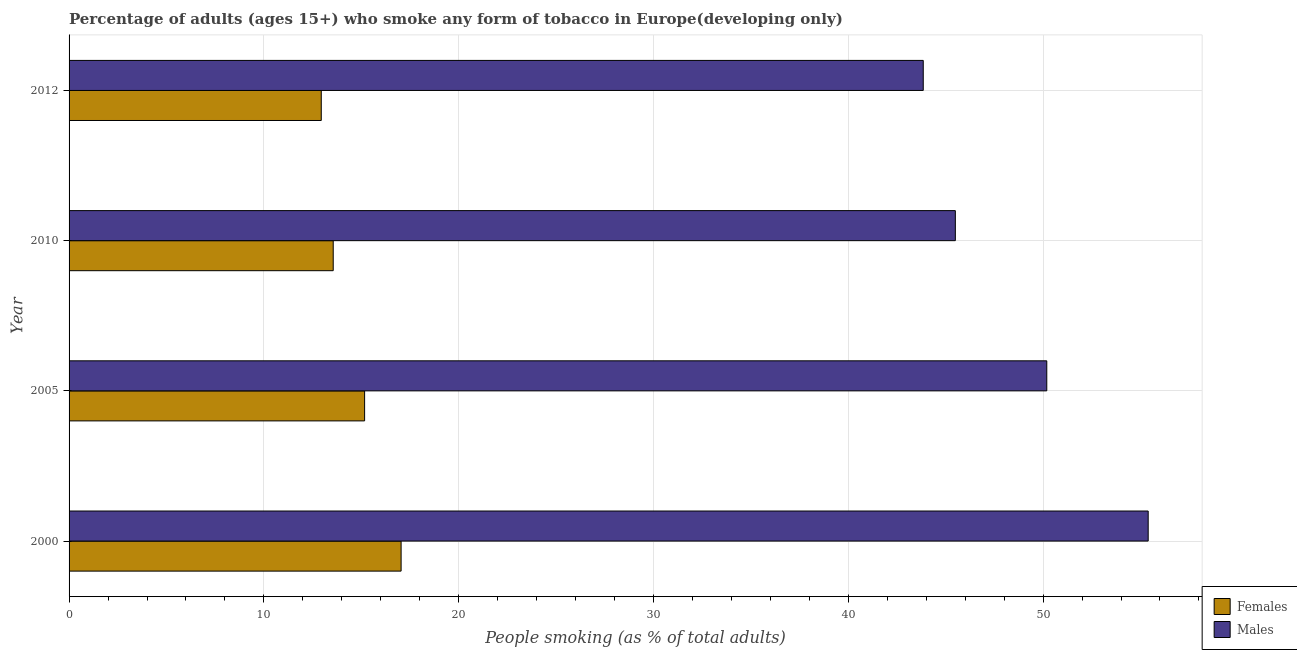How many different coloured bars are there?
Provide a succinct answer. 2. Are the number of bars on each tick of the Y-axis equal?
Your answer should be very brief. Yes. What is the label of the 1st group of bars from the top?
Your answer should be compact. 2012. In how many cases, is the number of bars for a given year not equal to the number of legend labels?
Provide a succinct answer. 0. What is the percentage of males who smoke in 2005?
Your answer should be very brief. 50.19. Across all years, what is the maximum percentage of males who smoke?
Your answer should be compact. 55.4. Across all years, what is the minimum percentage of females who smoke?
Give a very brief answer. 12.95. In which year was the percentage of males who smoke minimum?
Your response must be concise. 2012. What is the total percentage of males who smoke in the graph?
Provide a short and direct response. 194.93. What is the difference between the percentage of females who smoke in 2010 and that in 2012?
Your response must be concise. 0.61. What is the difference between the percentage of males who smoke in 2000 and the percentage of females who smoke in 2005?
Make the answer very short. 40.22. What is the average percentage of females who smoke per year?
Your answer should be very brief. 14.68. In the year 2005, what is the difference between the percentage of females who smoke and percentage of males who smoke?
Offer a very short reply. -35.02. In how many years, is the percentage of males who smoke greater than 50 %?
Your answer should be compact. 2. What is the ratio of the percentage of females who smoke in 2000 to that in 2010?
Provide a succinct answer. 1.26. What is the difference between the highest and the second highest percentage of females who smoke?
Give a very brief answer. 1.87. What is the difference between the highest and the lowest percentage of males who smoke?
Your answer should be compact. 11.55. What does the 1st bar from the top in 2010 represents?
Offer a terse response. Males. What does the 2nd bar from the bottom in 2010 represents?
Provide a succinct answer. Males. Are all the bars in the graph horizontal?
Keep it short and to the point. Yes. How many years are there in the graph?
Provide a short and direct response. 4. What is the difference between two consecutive major ticks on the X-axis?
Your answer should be very brief. 10. Are the values on the major ticks of X-axis written in scientific E-notation?
Provide a short and direct response. No. How are the legend labels stacked?
Ensure brevity in your answer.  Vertical. What is the title of the graph?
Your answer should be very brief. Percentage of adults (ages 15+) who smoke any form of tobacco in Europe(developing only). Does "Ages 15-24" appear as one of the legend labels in the graph?
Keep it short and to the point. No. What is the label or title of the X-axis?
Make the answer very short. People smoking (as % of total adults). What is the label or title of the Y-axis?
Provide a succinct answer. Year. What is the People smoking (as % of total adults) of Females in 2000?
Your answer should be very brief. 17.04. What is the People smoking (as % of total adults) of Males in 2000?
Give a very brief answer. 55.4. What is the People smoking (as % of total adults) of Females in 2005?
Make the answer very short. 15.17. What is the People smoking (as % of total adults) of Males in 2005?
Make the answer very short. 50.19. What is the People smoking (as % of total adults) in Females in 2010?
Your answer should be very brief. 13.56. What is the People smoking (as % of total adults) in Males in 2010?
Offer a terse response. 45.5. What is the People smoking (as % of total adults) in Females in 2012?
Give a very brief answer. 12.95. What is the People smoking (as % of total adults) in Males in 2012?
Provide a short and direct response. 43.85. Across all years, what is the maximum People smoking (as % of total adults) of Females?
Make the answer very short. 17.04. Across all years, what is the maximum People smoking (as % of total adults) of Males?
Your response must be concise. 55.4. Across all years, what is the minimum People smoking (as % of total adults) of Females?
Keep it short and to the point. 12.95. Across all years, what is the minimum People smoking (as % of total adults) in Males?
Keep it short and to the point. 43.85. What is the total People smoking (as % of total adults) of Females in the graph?
Give a very brief answer. 58.72. What is the total People smoking (as % of total adults) in Males in the graph?
Provide a succinct answer. 194.93. What is the difference between the People smoking (as % of total adults) of Females in 2000 and that in 2005?
Your answer should be very brief. 1.87. What is the difference between the People smoking (as % of total adults) in Males in 2000 and that in 2005?
Ensure brevity in your answer.  5.21. What is the difference between the People smoking (as % of total adults) of Females in 2000 and that in 2010?
Ensure brevity in your answer.  3.48. What is the difference between the People smoking (as % of total adults) of Males in 2000 and that in 2010?
Give a very brief answer. 9.9. What is the difference between the People smoking (as % of total adults) of Females in 2000 and that in 2012?
Give a very brief answer. 4.1. What is the difference between the People smoking (as % of total adults) of Males in 2000 and that in 2012?
Give a very brief answer. 11.55. What is the difference between the People smoking (as % of total adults) of Females in 2005 and that in 2010?
Make the answer very short. 1.61. What is the difference between the People smoking (as % of total adults) in Males in 2005 and that in 2010?
Your answer should be compact. 4.69. What is the difference between the People smoking (as % of total adults) in Females in 2005 and that in 2012?
Your answer should be very brief. 2.22. What is the difference between the People smoking (as % of total adults) in Males in 2005 and that in 2012?
Provide a succinct answer. 6.34. What is the difference between the People smoking (as % of total adults) in Females in 2010 and that in 2012?
Offer a terse response. 0.61. What is the difference between the People smoking (as % of total adults) of Males in 2010 and that in 2012?
Provide a short and direct response. 1.65. What is the difference between the People smoking (as % of total adults) in Females in 2000 and the People smoking (as % of total adults) in Males in 2005?
Your response must be concise. -33.15. What is the difference between the People smoking (as % of total adults) of Females in 2000 and the People smoking (as % of total adults) of Males in 2010?
Offer a very short reply. -28.45. What is the difference between the People smoking (as % of total adults) in Females in 2000 and the People smoking (as % of total adults) in Males in 2012?
Give a very brief answer. -26.8. What is the difference between the People smoking (as % of total adults) of Females in 2005 and the People smoking (as % of total adults) of Males in 2010?
Your response must be concise. -30.32. What is the difference between the People smoking (as % of total adults) in Females in 2005 and the People smoking (as % of total adults) in Males in 2012?
Provide a short and direct response. -28.68. What is the difference between the People smoking (as % of total adults) of Females in 2010 and the People smoking (as % of total adults) of Males in 2012?
Your answer should be very brief. -30.29. What is the average People smoking (as % of total adults) in Females per year?
Your answer should be compact. 14.68. What is the average People smoking (as % of total adults) in Males per year?
Your answer should be very brief. 48.73. In the year 2000, what is the difference between the People smoking (as % of total adults) of Females and People smoking (as % of total adults) of Males?
Give a very brief answer. -38.35. In the year 2005, what is the difference between the People smoking (as % of total adults) in Females and People smoking (as % of total adults) in Males?
Offer a very short reply. -35.02. In the year 2010, what is the difference between the People smoking (as % of total adults) in Females and People smoking (as % of total adults) in Males?
Keep it short and to the point. -31.94. In the year 2012, what is the difference between the People smoking (as % of total adults) in Females and People smoking (as % of total adults) in Males?
Your answer should be compact. -30.9. What is the ratio of the People smoking (as % of total adults) of Females in 2000 to that in 2005?
Provide a succinct answer. 1.12. What is the ratio of the People smoking (as % of total adults) of Males in 2000 to that in 2005?
Your answer should be compact. 1.1. What is the ratio of the People smoking (as % of total adults) in Females in 2000 to that in 2010?
Ensure brevity in your answer.  1.26. What is the ratio of the People smoking (as % of total adults) of Males in 2000 to that in 2010?
Your response must be concise. 1.22. What is the ratio of the People smoking (as % of total adults) of Females in 2000 to that in 2012?
Offer a terse response. 1.32. What is the ratio of the People smoking (as % of total adults) in Males in 2000 to that in 2012?
Ensure brevity in your answer.  1.26. What is the ratio of the People smoking (as % of total adults) in Females in 2005 to that in 2010?
Give a very brief answer. 1.12. What is the ratio of the People smoking (as % of total adults) in Males in 2005 to that in 2010?
Your answer should be very brief. 1.1. What is the ratio of the People smoking (as % of total adults) of Females in 2005 to that in 2012?
Give a very brief answer. 1.17. What is the ratio of the People smoking (as % of total adults) of Males in 2005 to that in 2012?
Ensure brevity in your answer.  1.14. What is the ratio of the People smoking (as % of total adults) of Females in 2010 to that in 2012?
Keep it short and to the point. 1.05. What is the ratio of the People smoking (as % of total adults) in Males in 2010 to that in 2012?
Ensure brevity in your answer.  1.04. What is the difference between the highest and the second highest People smoking (as % of total adults) of Females?
Your answer should be very brief. 1.87. What is the difference between the highest and the second highest People smoking (as % of total adults) of Males?
Make the answer very short. 5.21. What is the difference between the highest and the lowest People smoking (as % of total adults) of Females?
Make the answer very short. 4.1. What is the difference between the highest and the lowest People smoking (as % of total adults) of Males?
Your response must be concise. 11.55. 